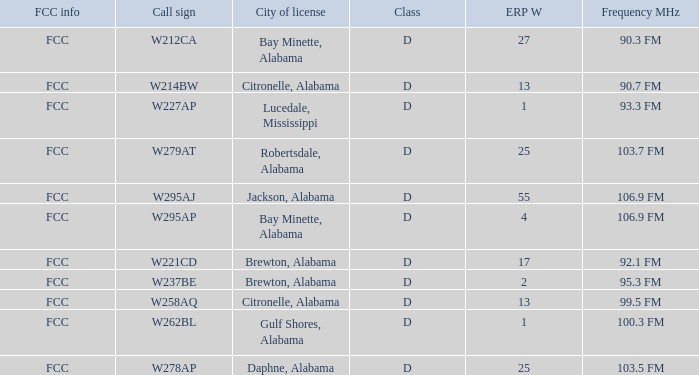Name the call sign for ERP W of 4 W295AP. 